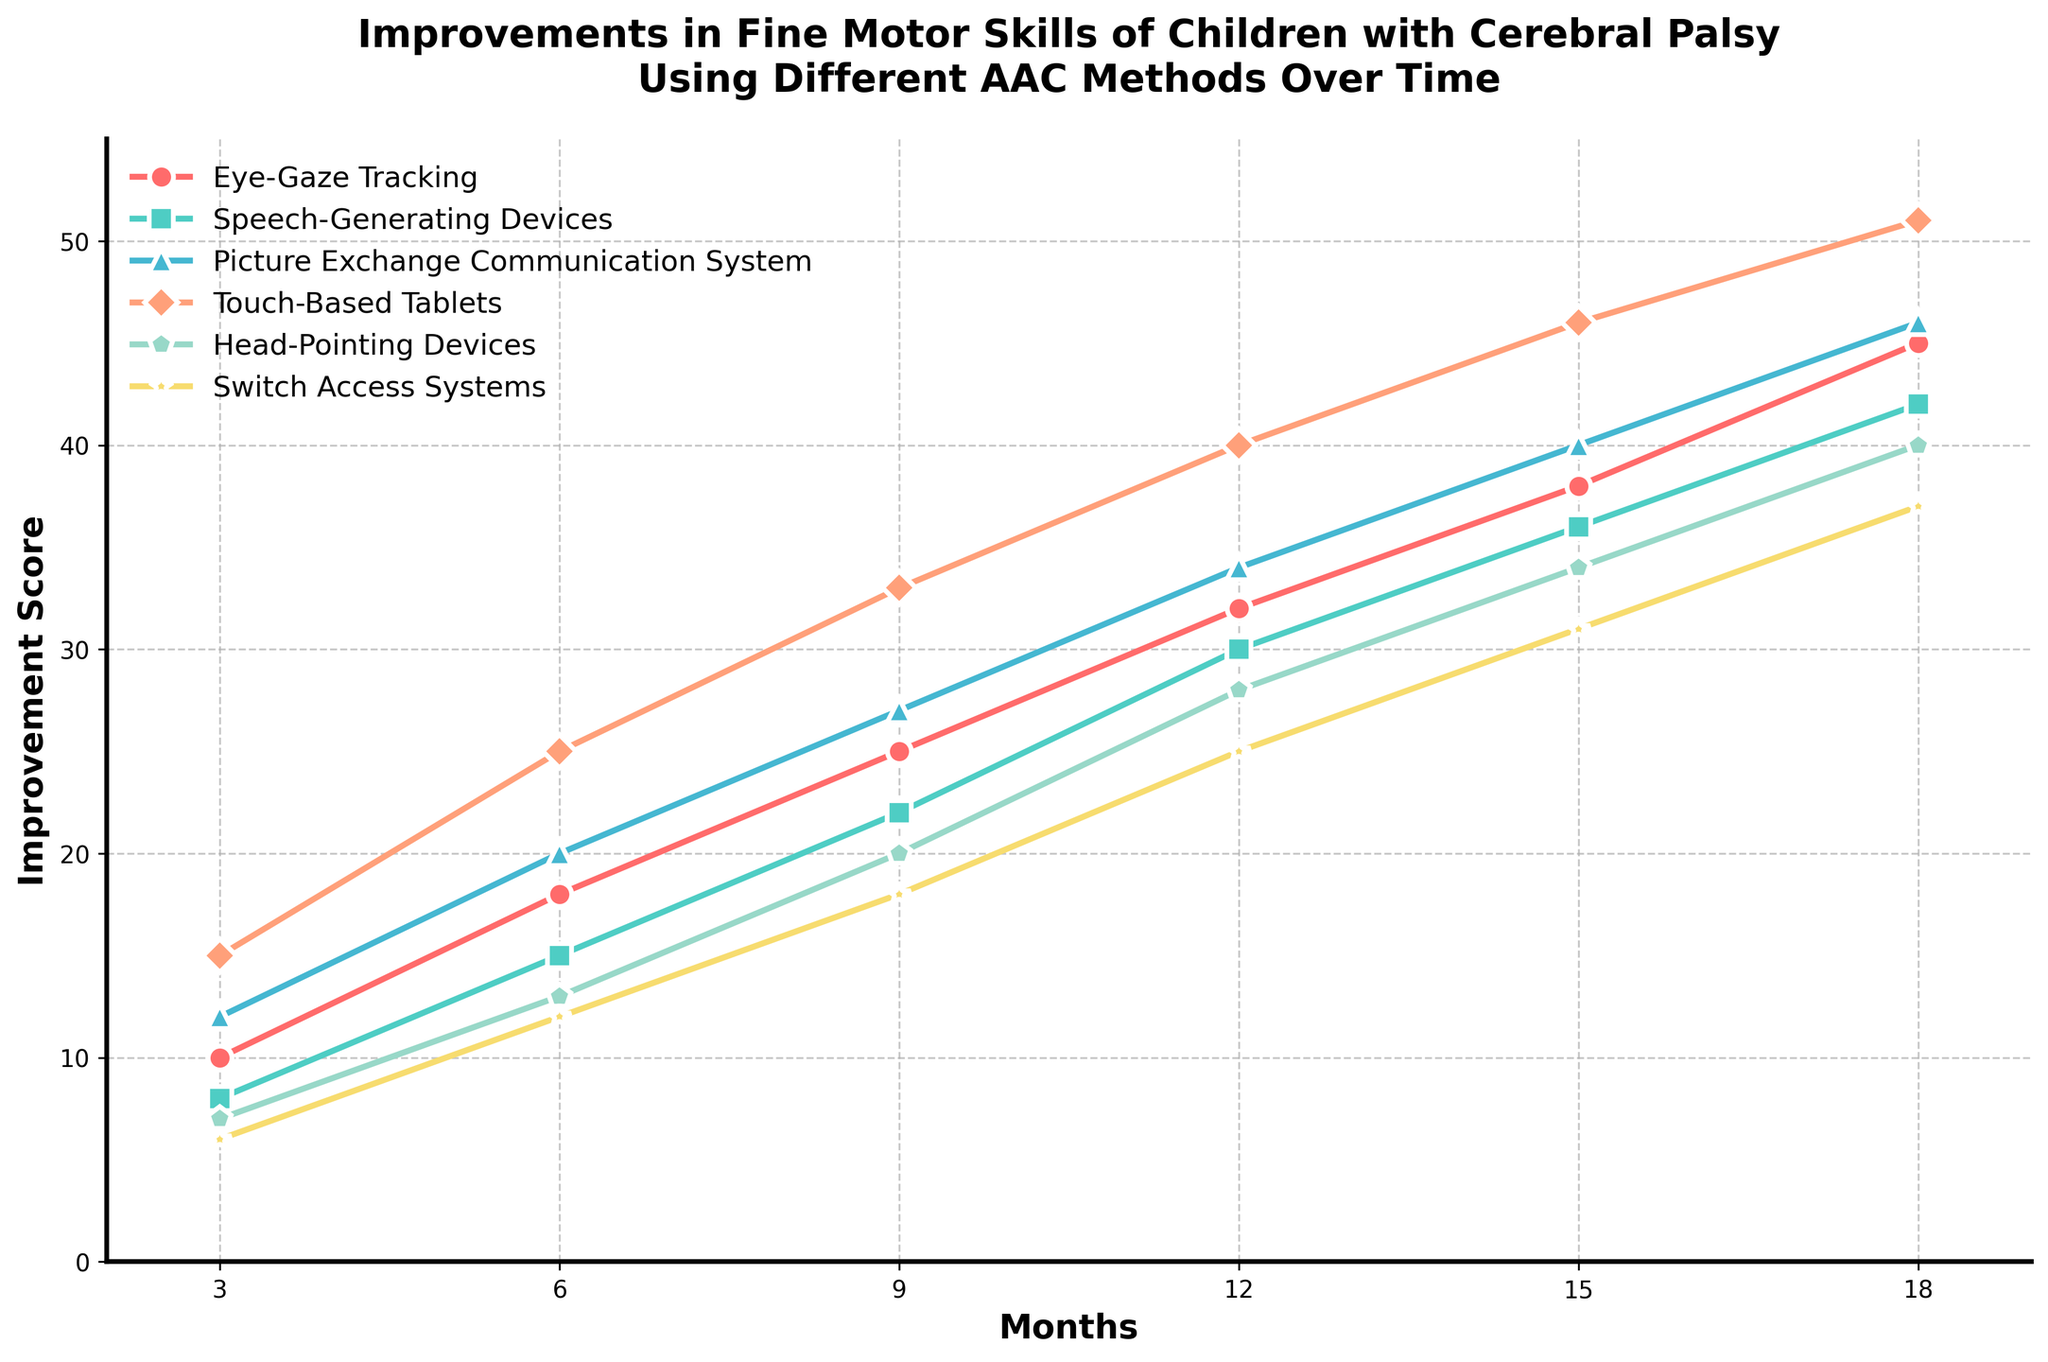Which method shows the highest improvement after 18 months? Look at the end points of all the line plots, the highest point corresponds to Touch-Based Tablets.
Answer: Touch-Based Tablets Which AAC method shows the least improvement after 6 months? Find the value at 6 months for all methods. The method with the smallest value is Switch Access Systems.
Answer: Switch Access Systems How much improvement is seen in Eye-Gaze Tracking between 9 and 15 months? The improvement score at 9 months is 25 and at 15 months is 38. The increase is 38 - 25.
Answer: 13 Which two methods have the closest improvement scores at 12 months? Compare the scores at 12 months for all methods. Eye-Gaze Tracking has 32, Speech-Generating Devices has 30, Picture Exchange Communication System has 34, Touch-Based Tablets has 40, Head-Pointing Devices has 28, and Switch Access Systems has 25. The closest are Eye-Gaze Tracking and Picture Exchange Communication System, with a difference of 2.
Answer: Eye-Gaze Tracking and Picture Exchange Communication System Does any method exhibit a consistent linear increase over time? Check each line for linearity. Speech-Generating Devices, Eye-Gaze Tracking, and Switch Access Systems all show a relatively consistent linear increase.
Answer: Yes, Speech-Generating Devices, Eye-Gaze Tracking, and Switch Access Systems Between 3 and 18 months, which method shows the second largest overall improvement? Calculate the improvement from 3 to 18 months for all methods: 
Eye-Gaze Tracking = 45 - 10 = 35 
Speech-Generating Devices = 42 - 8 = 34 
Picture Exchange Communication System = 46 - 12 = 34 
Touch-Based Tablets = 51 - 15 = 36 
Head-Pointing Devices = 40 - 7 = 33 
Switch Access Systems = 37 - 6 = 31. The second largest is by Eye-Gaze Tracking.
Answer: Eye-Gaze Tracking 